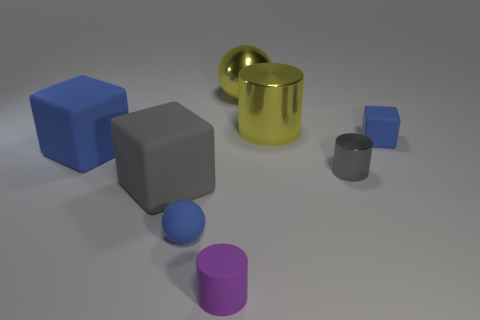Subtract all small gray shiny cylinders. How many cylinders are left? 2 Subtract all yellow cylinders. How many cylinders are left? 2 Subtract all cylinders. How many objects are left? 5 Subtract 2 cubes. How many cubes are left? 1 Subtract all brown spheres. How many gray cylinders are left? 1 Add 3 purple things. How many purple things are left? 4 Add 2 big blue matte spheres. How many big blue matte spheres exist? 2 Add 2 gray things. How many objects exist? 10 Subtract 0 red blocks. How many objects are left? 8 Subtract all yellow blocks. Subtract all yellow cylinders. How many blocks are left? 3 